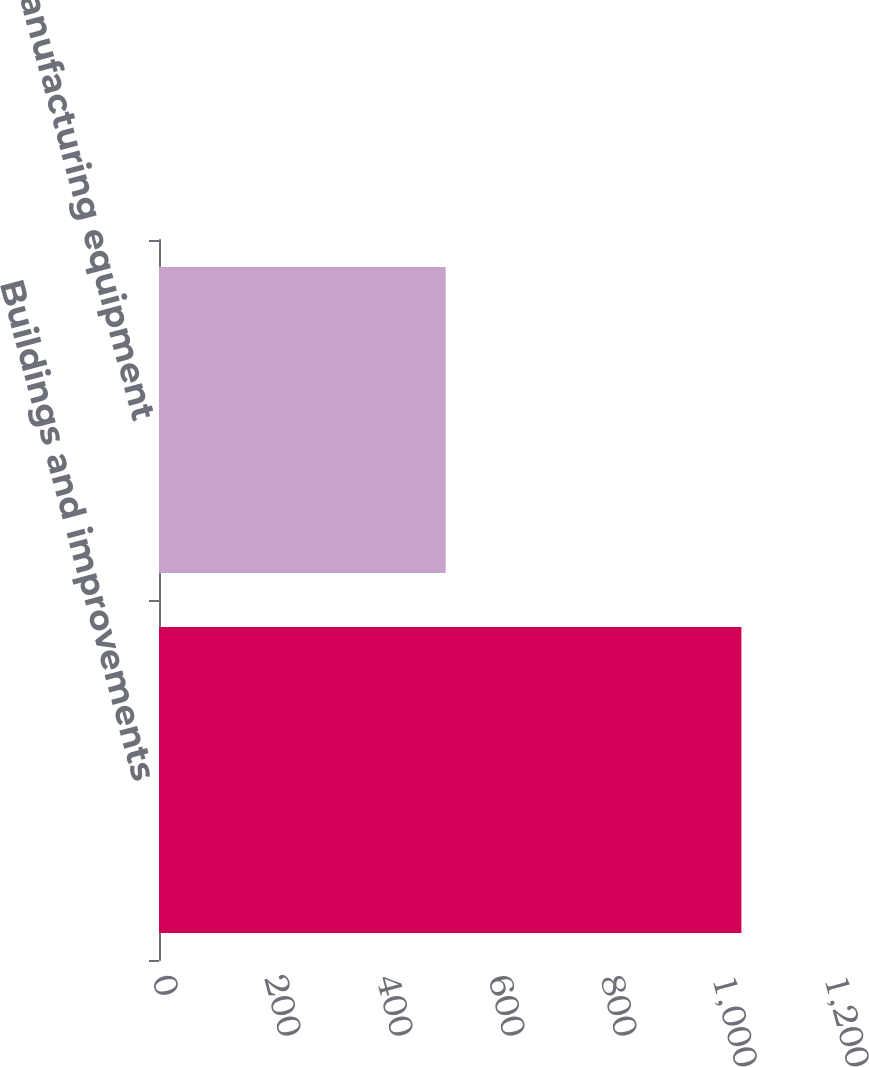Convert chart. <chart><loc_0><loc_0><loc_500><loc_500><bar_chart><fcel>Buildings and improvements<fcel>Manufacturing equipment<nl><fcel>1040<fcel>512<nl></chart> 